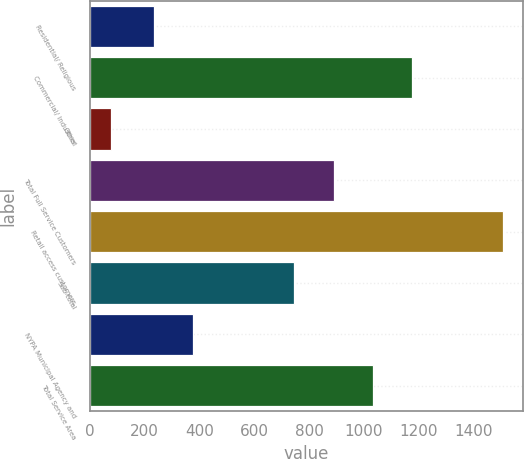<chart> <loc_0><loc_0><loc_500><loc_500><bar_chart><fcel>Residential/ Religious<fcel>Commercial/ Industrial<fcel>Other<fcel>Total Full Service Customers<fcel>Retail access customers<fcel>Sub-total<fcel>NYPA Municipal Agency and<fcel>Total Service Area<nl><fcel>232<fcel>1175.3<fcel>75<fcel>889.1<fcel>1506<fcel>746<fcel>375.1<fcel>1032.2<nl></chart> 